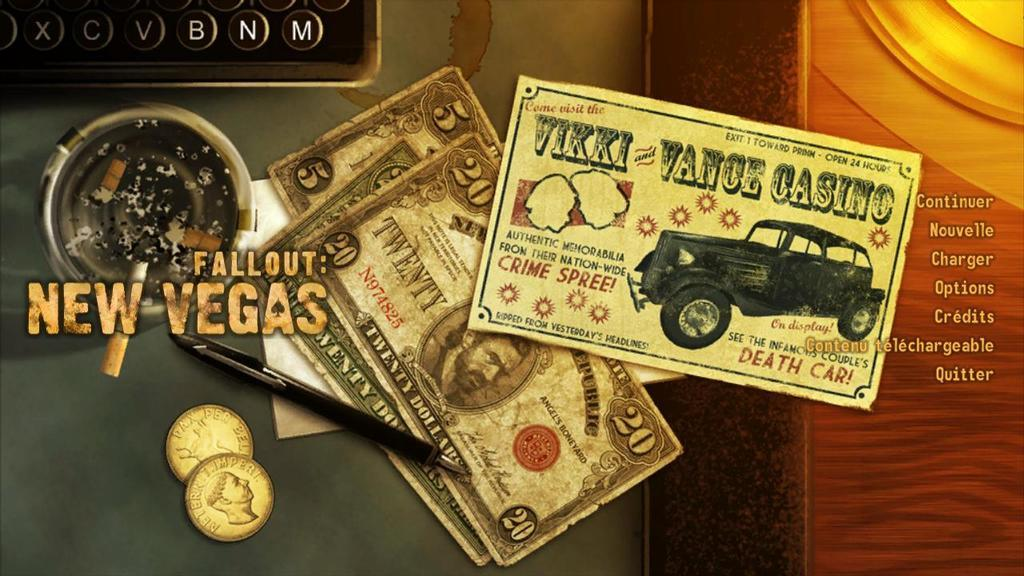Provide a one-sentence caption for the provided image. A card from Vikki Vance Casino is shown here. 